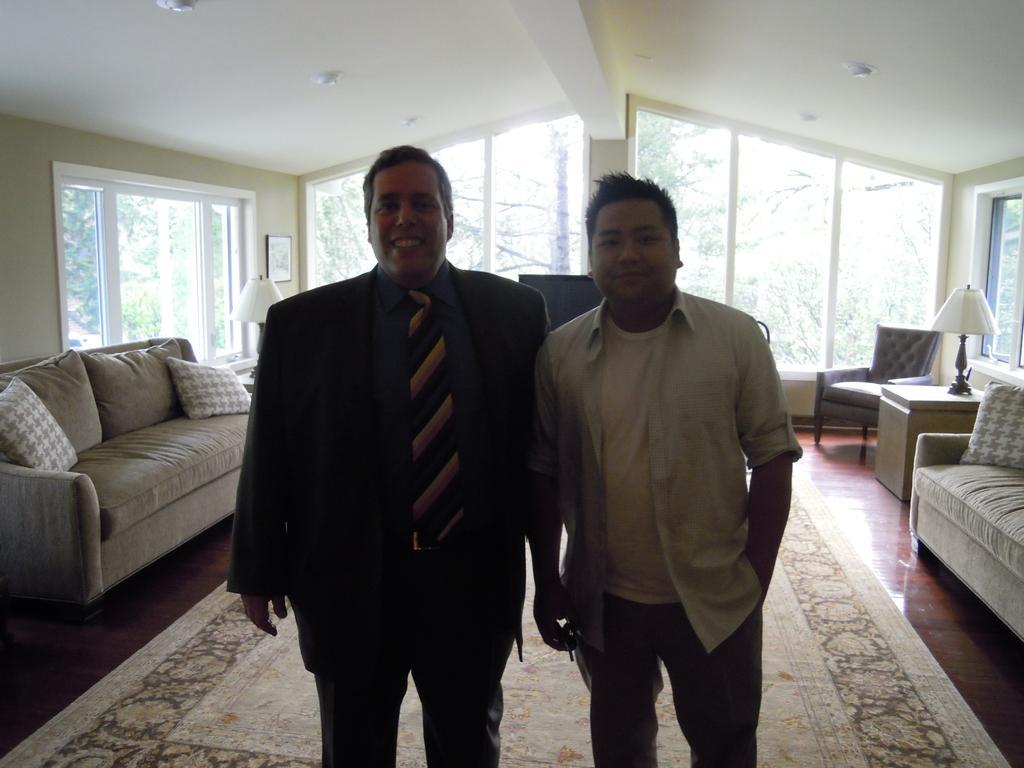Describe this image in one or two sentences. The image is inside the room. In the image there are two men, on left side there is a man standing and wearing a black color suit and he is also having a smile on his face. On right side we can see a couch,table,lamp,windows which are closed. On left side we can see a door which are closed and a couch with pillows,lamp,photo frames on wall and the wall is in cream color. On top there is a roof with few lights at bottom there is mat. 